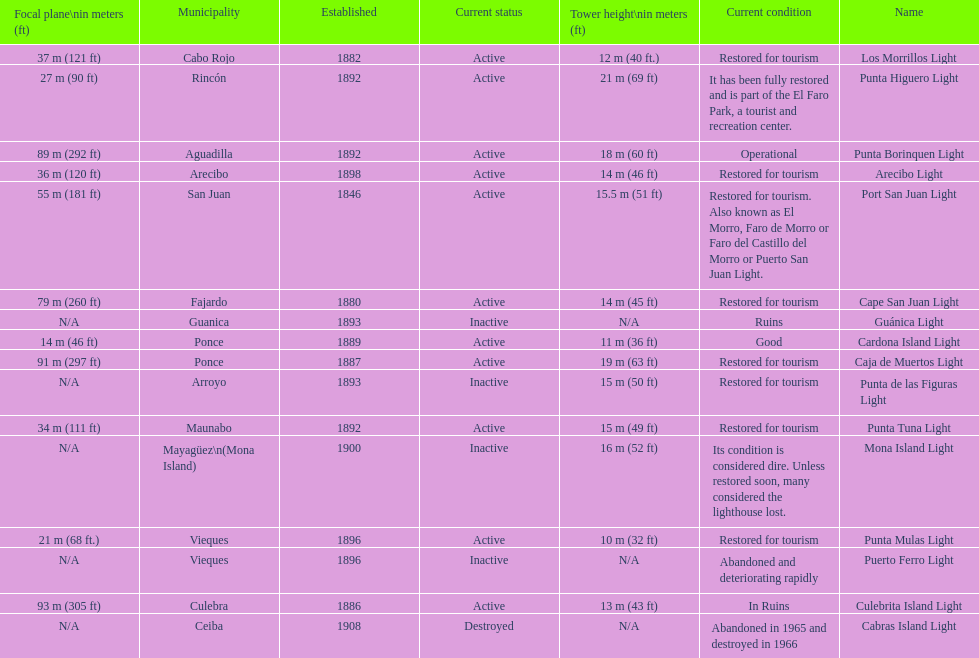How many towers are at least 18 meters tall? 3. 